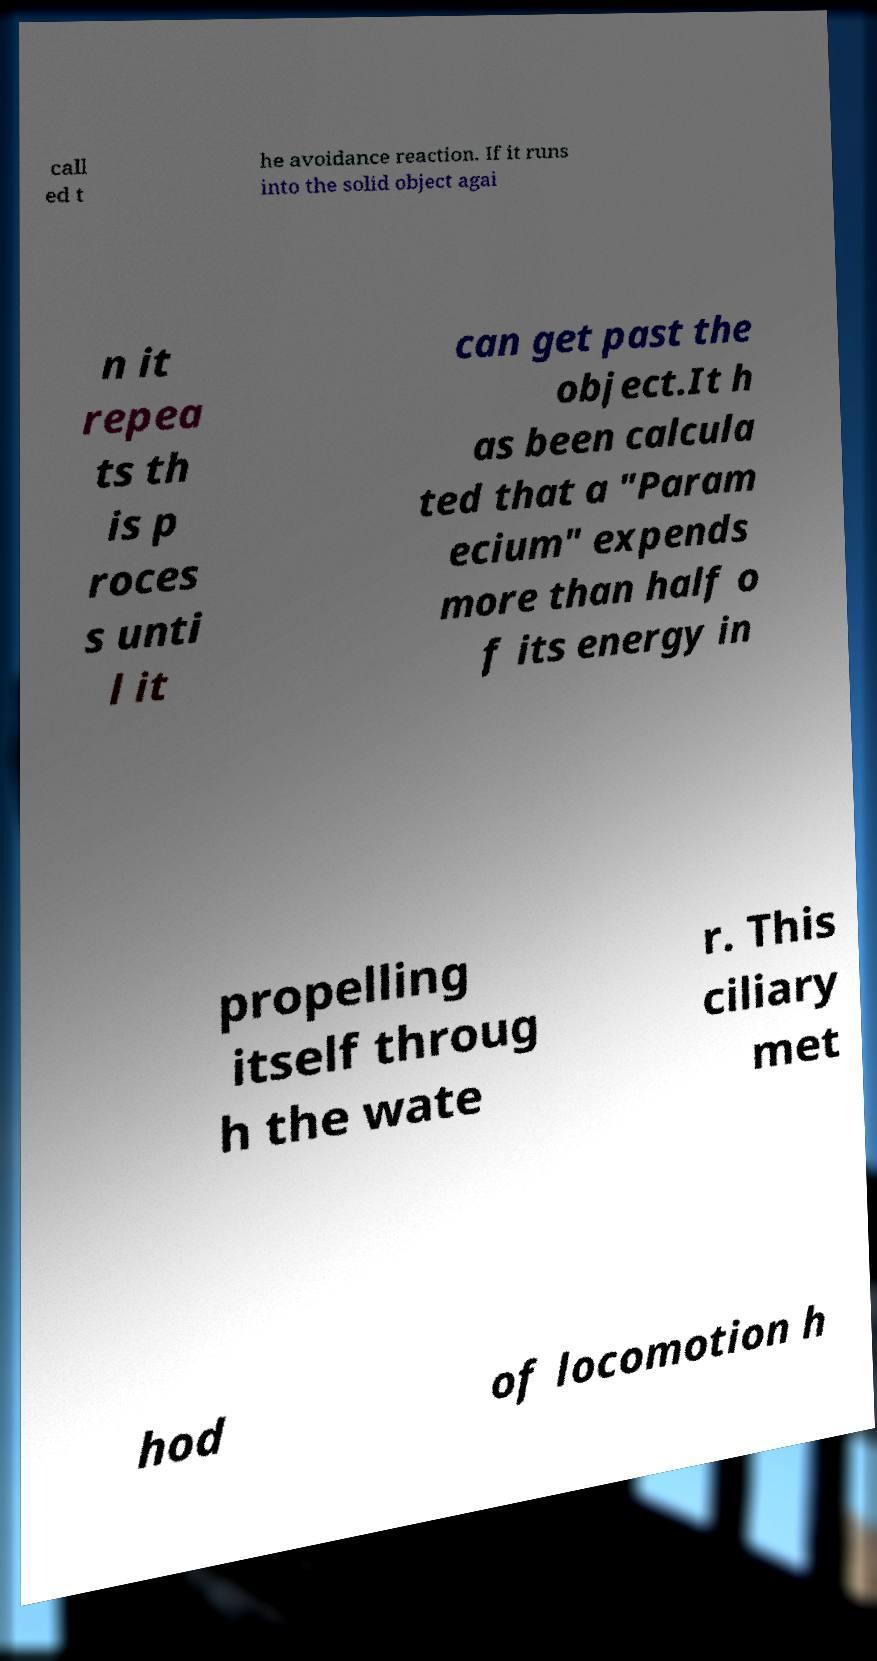Could you assist in decoding the text presented in this image and type it out clearly? call ed t he avoidance reaction. If it runs into the solid object agai n it repea ts th is p roces s unti l it can get past the object.It h as been calcula ted that a "Param ecium" expends more than half o f its energy in propelling itself throug h the wate r. This ciliary met hod of locomotion h 